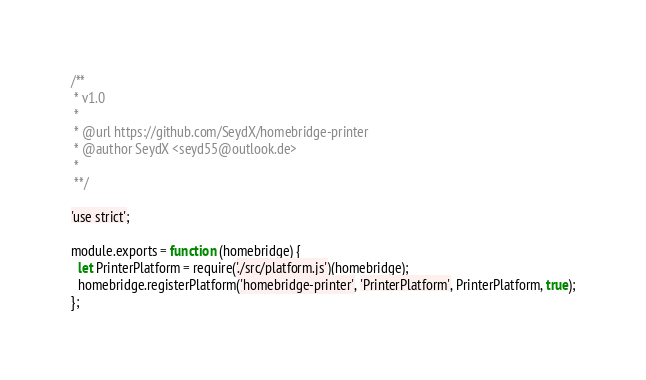Convert code to text. <code><loc_0><loc_0><loc_500><loc_500><_JavaScript_>/**
 * v1.0
 *
 * @url https://github.com/SeydX/homebridge-printer
 * @author SeydX <seyd55@outlook.de>
 *
 **/

'use strict';

module.exports = function (homebridge) {
  let PrinterPlatform = require('./src/platform.js')(homebridge);
  homebridge.registerPlatform('homebridge-printer', 'PrinterPlatform', PrinterPlatform, true);
};
</code> 